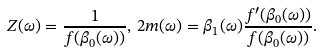<formula> <loc_0><loc_0><loc_500><loc_500>Z ( \omega ) = \frac { 1 } { f ( \beta _ { 0 } ( \omega ) ) } , \, 2 m ( \omega ) = \beta _ { 1 } ( \omega ) \frac { f ^ { \prime } ( \beta _ { 0 } ( \omega ) ) } { f ( \beta _ { 0 } ( \omega ) ) } .</formula> 